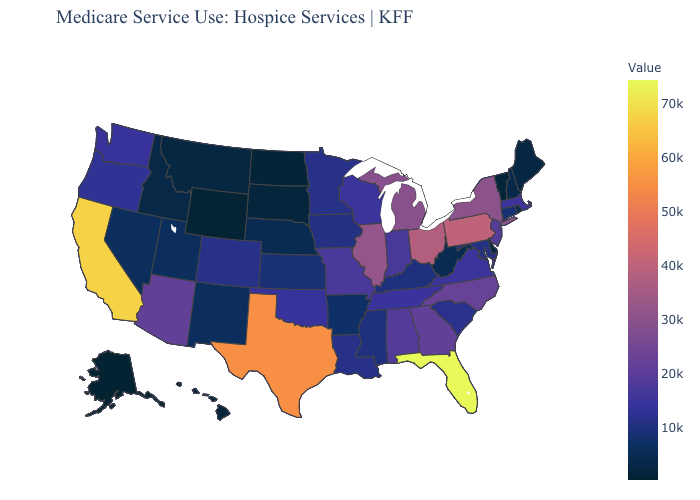Among the states that border Idaho , which have the highest value?
Answer briefly. Washington. Does Michigan have a lower value than Rhode Island?
Concise answer only. No. Which states have the highest value in the USA?
Write a very short answer. Florida. Which states have the lowest value in the USA?
Write a very short answer. Alaska. Does Tennessee have a higher value than Florida?
Be succinct. No. 